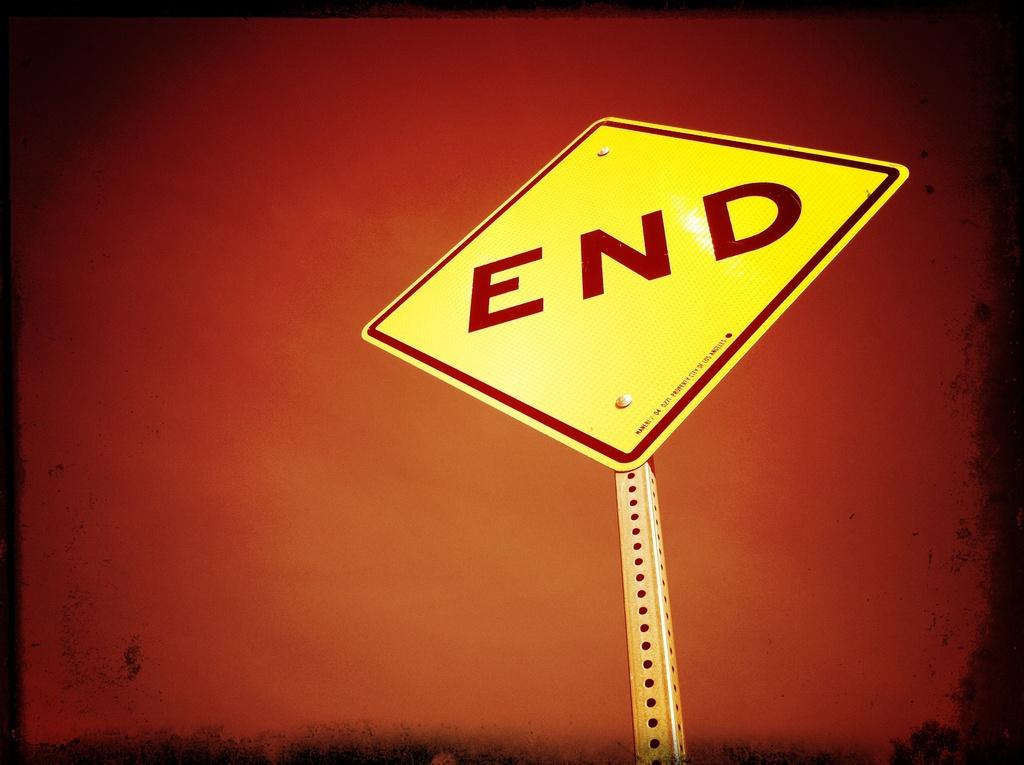When you come to this sign, what should you do?
Your answer should be very brief. End. What does the sign read?
Provide a short and direct response. End. 